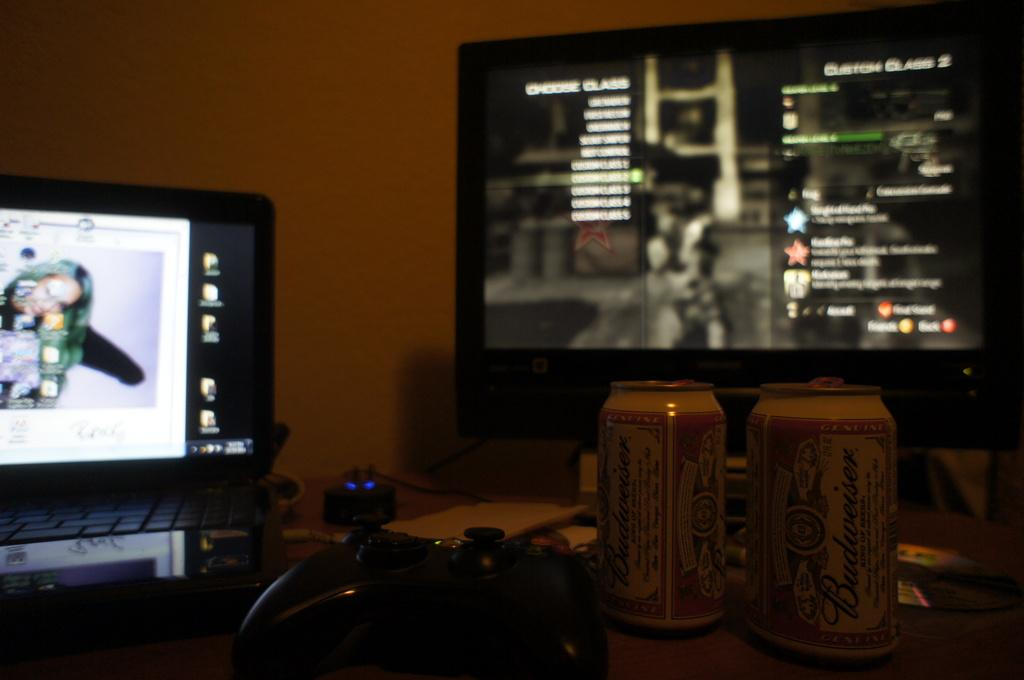<image>
Give a short and clear explanation of the subsequent image. Two cans of Budweiser in front of a flat screen TV. 